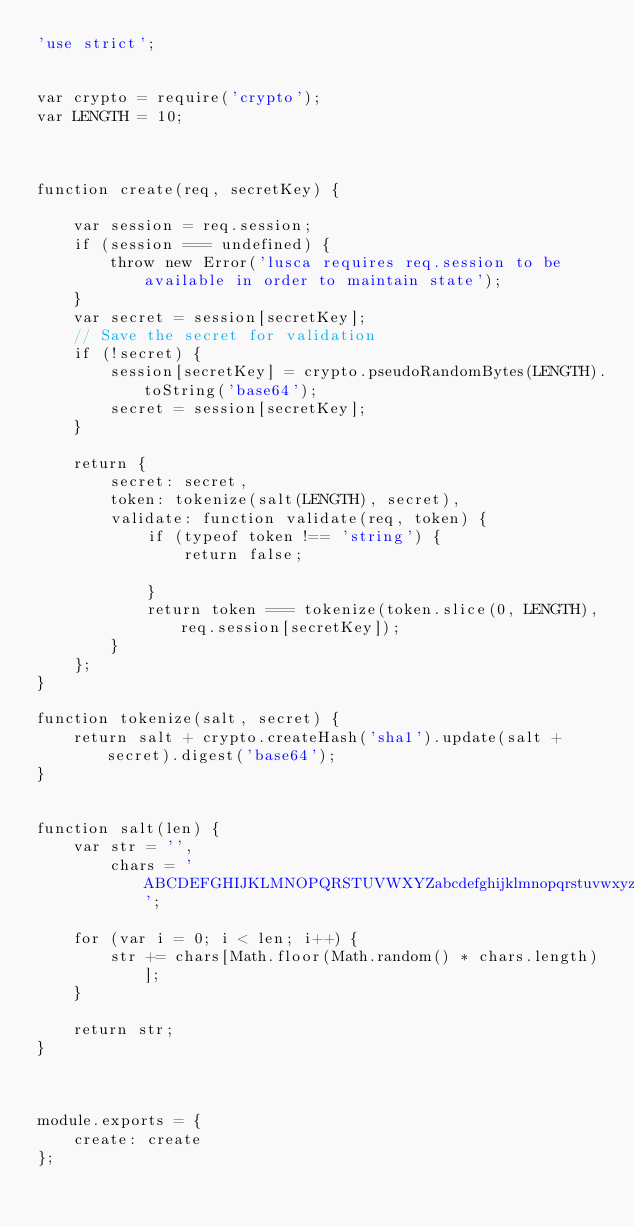<code> <loc_0><loc_0><loc_500><loc_500><_JavaScript_>'use strict';


var crypto = require('crypto');
var LENGTH = 10;



function create(req, secretKey) {

    var session = req.session;
    if (session === undefined) {
        throw new Error('lusca requires req.session to be available in order to maintain state');
    }
    var secret = session[secretKey];
    // Save the secret for validation
    if (!secret) {
        session[secretKey] = crypto.pseudoRandomBytes(LENGTH).toString('base64');
        secret = session[secretKey];
    }

    return {
        secret: secret,
        token: tokenize(salt(LENGTH), secret),
        validate: function validate(req, token) {
            if (typeof token !== 'string') {
                return false;

            }
            return token === tokenize(token.slice(0, LENGTH), req.session[secretKey]);
        }
    };
}

function tokenize(salt, secret) {
    return salt + crypto.createHash('sha1').update(salt + secret).digest('base64');
}


function salt(len) {
    var str = '',
        chars = 'ABCDEFGHIJKLMNOPQRSTUVWXYZabcdefghijklmnopqrstuvwxyz0123456789';

    for (var i = 0; i < len; i++) {
        str += chars[Math.floor(Math.random() * chars.length)];
    }

    return str;
}



module.exports = {
    create: create
};
</code> 